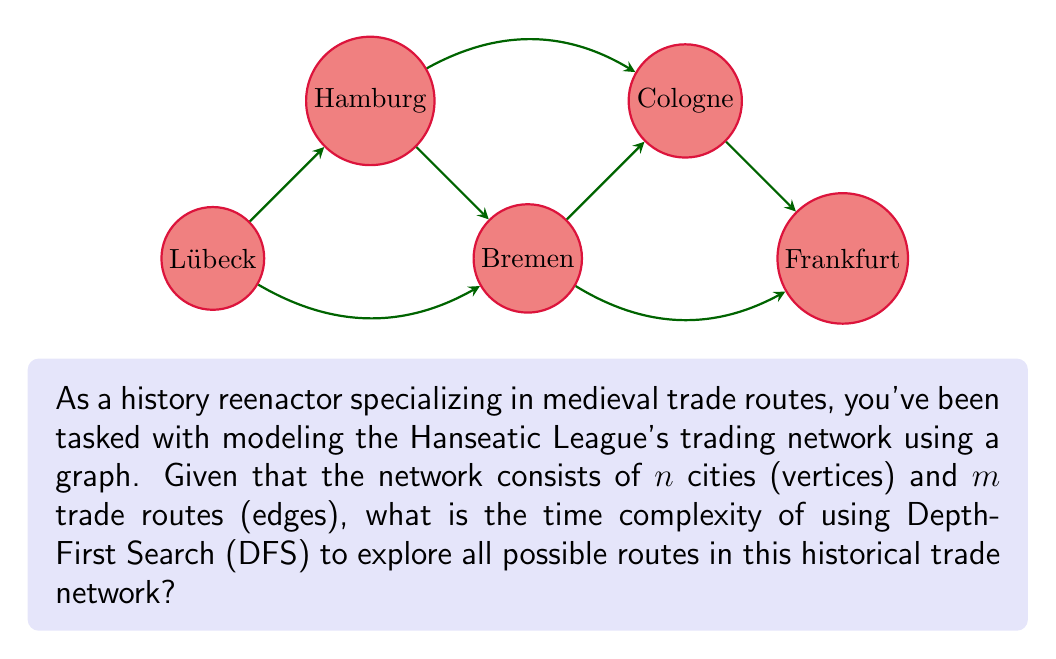Help me with this question. To determine the time complexity of Depth-First Search (DFS) for exploring the Hanseatic League's trade network, we need to consider the following steps:

1) In DFS, we visit each vertex once and explore all its adjacent edges.

2) For each vertex:
   - We mark it as visited: $O(1)$ operation
   - We explore all its adjacent edges: $O(degree(v))$ where $v$ is the current vertex

3) The sum of degrees of all vertices in an undirected graph is equal to twice the number of edges: $\sum_{v \in V} degree(v) = 2m$

4) Therefore, the total time to explore all edges is $O(m)$

5) We also need to consider the initialization of data structures:
   - Marking all vertices as unvisited: $O(n)$
   - Creating an adjacency list representation: $O(n + m)$

6) Combining all these operations:
   $T(n,m) = O(n) + O(m) + O(n + m) = O(n + m)$

7) In the worst case, when the graph is connected, $m \geq n - 1$, so we can simplify this to $O(m)$

Therefore, the time complexity of DFS for exploring this historical trade network is $O(m)$, where $m$ is the number of trade routes.
Answer: $O(m)$ 